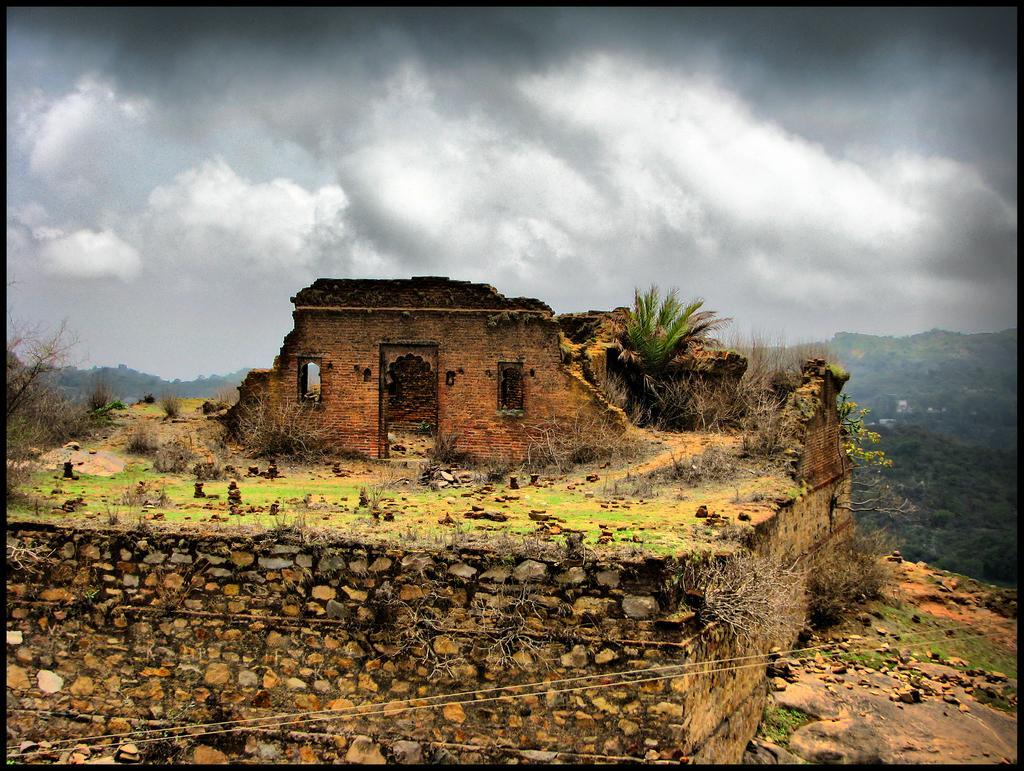Could you give a brief overview of what you see in this image? There is a collapsed building and there are few other objects beside it and there are trees in the background and the sky is cloudy. 